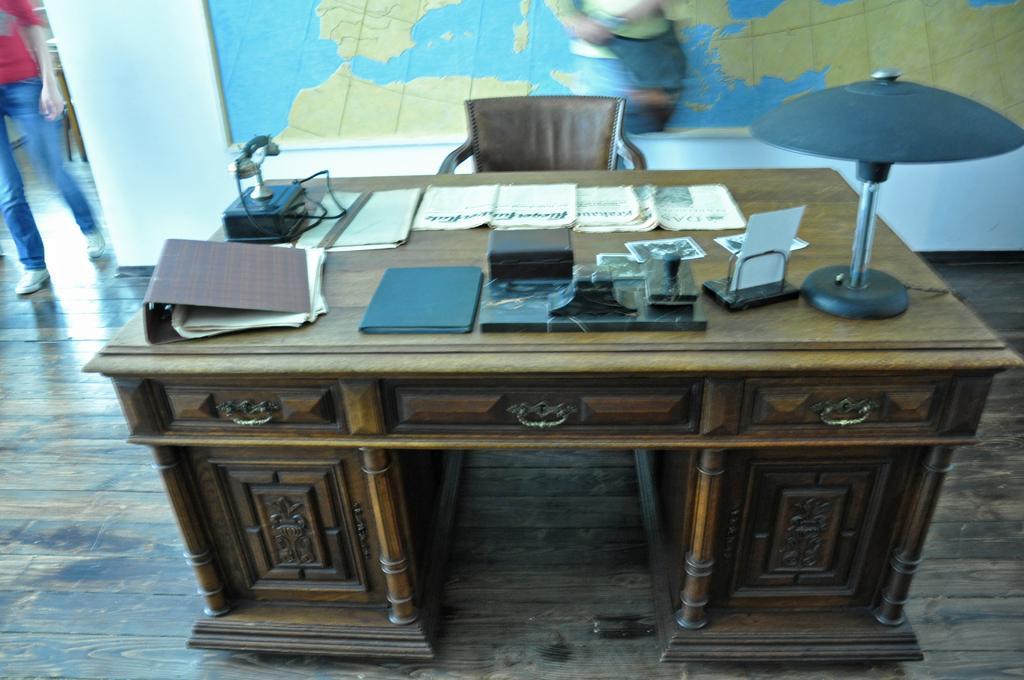Could you give a brief overview of what you see in this image? In this image on a table there are folders, books, telephone, box, lamp few other things are there. Here there is a chair. In the background there is a map. Here a person is walking. The floor is wooden furnished. 